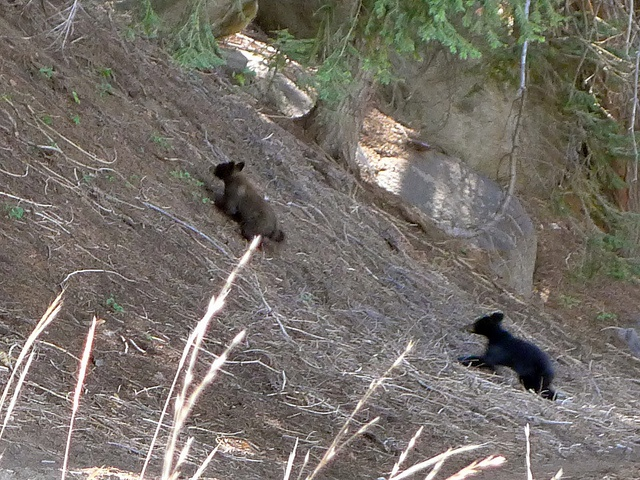Describe the objects in this image and their specific colors. I can see bear in gray, black, and darkgray tones and bear in gray and black tones in this image. 